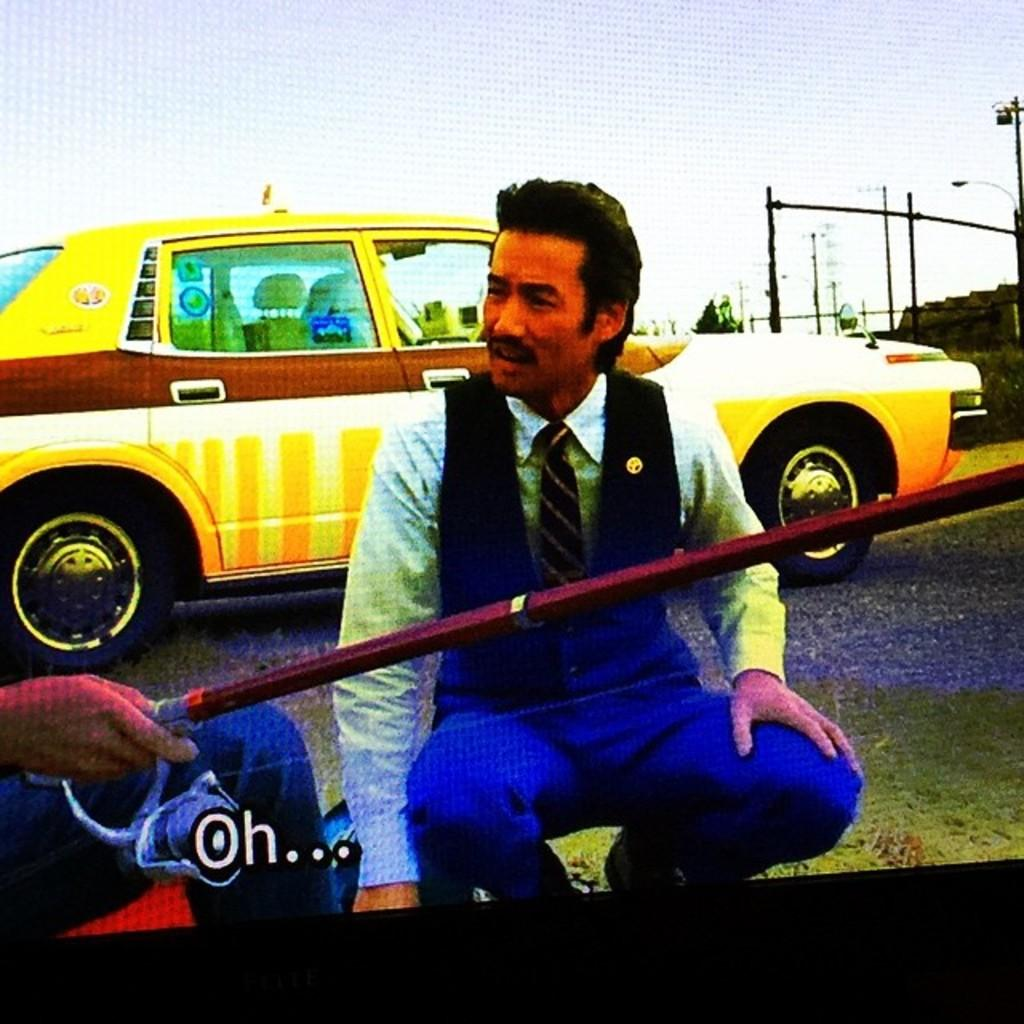<image>
Offer a succinct explanation of the picture presented. A TV show's subtitles appear with the exclamatuion, "Oh." 